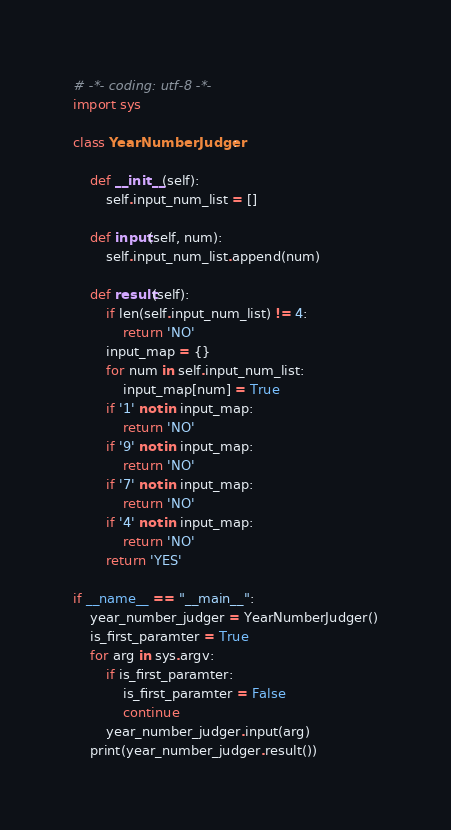Convert code to text. <code><loc_0><loc_0><loc_500><loc_500><_Python_># -*- coding: utf-8 -*-
import sys

class YearNumberJudger:

    def __init__(self):
        self.input_num_list = []

    def input(self, num):
        self.input_num_list.append(num)

    def result(self):
        if len(self.input_num_list) != 4:
            return 'NO'
        input_map = {}
        for num in self.input_num_list:
            input_map[num] = True
        if '1' not in input_map:
            return 'NO'
        if '9' not in input_map:
            return 'NO'
        if '7' not in input_map:
            return 'NO'
        if '4' not in input_map:
            return 'NO'
        return 'YES'

if __name__ == "__main__":
    year_number_judger = YearNumberJudger()
    is_first_paramter = True
    for arg in sys.argv:
        if is_first_paramter:
            is_first_paramter = False
            continue
        year_number_judger.input(arg)
    print(year_number_judger.result())
</code> 